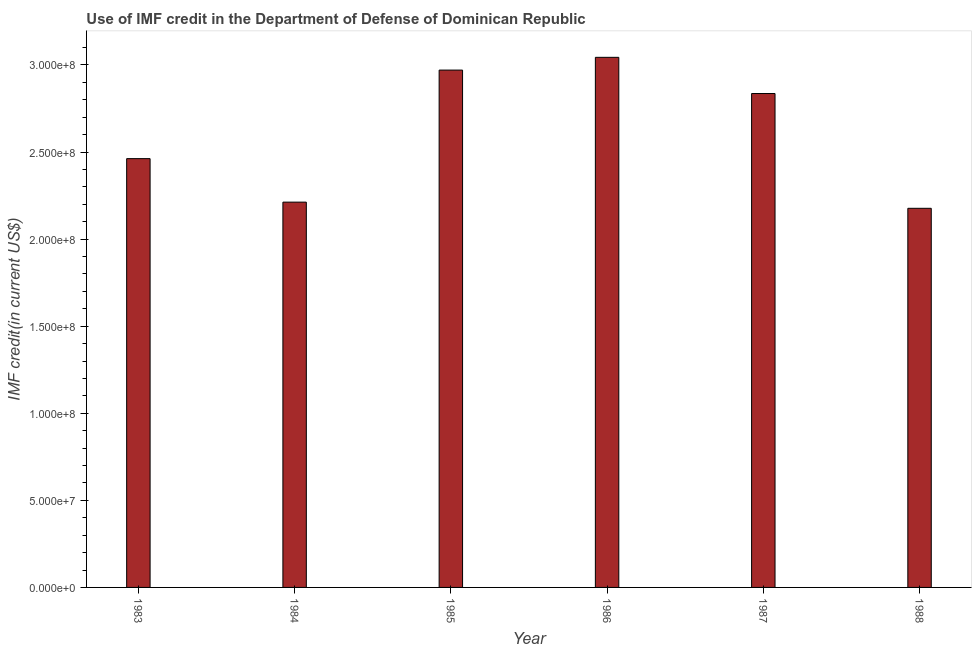Does the graph contain grids?
Ensure brevity in your answer.  No. What is the title of the graph?
Your response must be concise. Use of IMF credit in the Department of Defense of Dominican Republic. What is the label or title of the Y-axis?
Provide a short and direct response. IMF credit(in current US$). What is the use of imf credit in dod in 1986?
Provide a succinct answer. 3.04e+08. Across all years, what is the maximum use of imf credit in dod?
Offer a very short reply. 3.04e+08. Across all years, what is the minimum use of imf credit in dod?
Your answer should be very brief. 2.18e+08. In which year was the use of imf credit in dod maximum?
Offer a very short reply. 1986. In which year was the use of imf credit in dod minimum?
Offer a terse response. 1988. What is the sum of the use of imf credit in dod?
Give a very brief answer. 1.57e+09. What is the difference between the use of imf credit in dod in 1985 and 1987?
Your answer should be very brief. 1.35e+07. What is the average use of imf credit in dod per year?
Offer a very short reply. 2.62e+08. What is the median use of imf credit in dod?
Make the answer very short. 2.65e+08. In how many years, is the use of imf credit in dod greater than 120000000 US$?
Make the answer very short. 6. Do a majority of the years between 1987 and 1988 (inclusive) have use of imf credit in dod greater than 10000000 US$?
Give a very brief answer. Yes. What is the ratio of the use of imf credit in dod in 1983 to that in 1984?
Your answer should be very brief. 1.11. Is the difference between the use of imf credit in dod in 1983 and 1985 greater than the difference between any two years?
Give a very brief answer. No. What is the difference between the highest and the second highest use of imf credit in dod?
Your answer should be compact. 7.32e+06. Is the sum of the use of imf credit in dod in 1985 and 1986 greater than the maximum use of imf credit in dod across all years?
Provide a succinct answer. Yes. What is the difference between the highest and the lowest use of imf credit in dod?
Make the answer very short. 8.67e+07. How many bars are there?
Offer a very short reply. 6. Are all the bars in the graph horizontal?
Give a very brief answer. No. How many years are there in the graph?
Offer a terse response. 6. What is the difference between two consecutive major ticks on the Y-axis?
Provide a short and direct response. 5.00e+07. Are the values on the major ticks of Y-axis written in scientific E-notation?
Your answer should be very brief. Yes. What is the IMF credit(in current US$) in 1983?
Give a very brief answer. 2.46e+08. What is the IMF credit(in current US$) of 1984?
Provide a succinct answer. 2.21e+08. What is the IMF credit(in current US$) in 1985?
Offer a terse response. 2.97e+08. What is the IMF credit(in current US$) in 1986?
Your answer should be very brief. 3.04e+08. What is the IMF credit(in current US$) of 1987?
Make the answer very short. 2.84e+08. What is the IMF credit(in current US$) in 1988?
Give a very brief answer. 2.18e+08. What is the difference between the IMF credit(in current US$) in 1983 and 1984?
Your answer should be compact. 2.50e+07. What is the difference between the IMF credit(in current US$) in 1983 and 1985?
Your answer should be very brief. -5.08e+07. What is the difference between the IMF credit(in current US$) in 1983 and 1986?
Make the answer very short. -5.82e+07. What is the difference between the IMF credit(in current US$) in 1983 and 1987?
Provide a succinct answer. -3.74e+07. What is the difference between the IMF credit(in current US$) in 1983 and 1988?
Give a very brief answer. 2.85e+07. What is the difference between the IMF credit(in current US$) in 1984 and 1985?
Offer a terse response. -7.58e+07. What is the difference between the IMF credit(in current US$) in 1984 and 1986?
Give a very brief answer. -8.31e+07. What is the difference between the IMF credit(in current US$) in 1984 and 1987?
Give a very brief answer. -6.24e+07. What is the difference between the IMF credit(in current US$) in 1984 and 1988?
Give a very brief answer. 3.54e+06. What is the difference between the IMF credit(in current US$) in 1985 and 1986?
Keep it short and to the point. -7.32e+06. What is the difference between the IMF credit(in current US$) in 1985 and 1987?
Provide a succinct answer. 1.35e+07. What is the difference between the IMF credit(in current US$) in 1985 and 1988?
Provide a short and direct response. 7.94e+07. What is the difference between the IMF credit(in current US$) in 1986 and 1987?
Make the answer very short. 2.08e+07. What is the difference between the IMF credit(in current US$) in 1986 and 1988?
Ensure brevity in your answer.  8.67e+07. What is the difference between the IMF credit(in current US$) in 1987 and 1988?
Your answer should be compact. 6.59e+07. What is the ratio of the IMF credit(in current US$) in 1983 to that in 1984?
Offer a very short reply. 1.11. What is the ratio of the IMF credit(in current US$) in 1983 to that in 1985?
Make the answer very short. 0.83. What is the ratio of the IMF credit(in current US$) in 1983 to that in 1986?
Your response must be concise. 0.81. What is the ratio of the IMF credit(in current US$) in 1983 to that in 1987?
Make the answer very short. 0.87. What is the ratio of the IMF credit(in current US$) in 1983 to that in 1988?
Provide a succinct answer. 1.13. What is the ratio of the IMF credit(in current US$) in 1984 to that in 1985?
Keep it short and to the point. 0.74. What is the ratio of the IMF credit(in current US$) in 1984 to that in 1986?
Provide a short and direct response. 0.73. What is the ratio of the IMF credit(in current US$) in 1984 to that in 1987?
Your answer should be very brief. 0.78. What is the ratio of the IMF credit(in current US$) in 1984 to that in 1988?
Your response must be concise. 1.02. What is the ratio of the IMF credit(in current US$) in 1985 to that in 1986?
Your answer should be compact. 0.98. What is the ratio of the IMF credit(in current US$) in 1985 to that in 1987?
Keep it short and to the point. 1.05. What is the ratio of the IMF credit(in current US$) in 1985 to that in 1988?
Provide a succinct answer. 1.36. What is the ratio of the IMF credit(in current US$) in 1986 to that in 1987?
Make the answer very short. 1.07. What is the ratio of the IMF credit(in current US$) in 1986 to that in 1988?
Provide a short and direct response. 1.4. What is the ratio of the IMF credit(in current US$) in 1987 to that in 1988?
Offer a terse response. 1.3. 